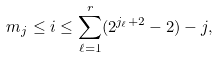Convert formula to latex. <formula><loc_0><loc_0><loc_500><loc_500>m _ { j } \leq i \leq \sum _ { \ell = 1 } ^ { r } ( 2 ^ { j _ { \ell } + 2 } - 2 ) - j ,</formula> 